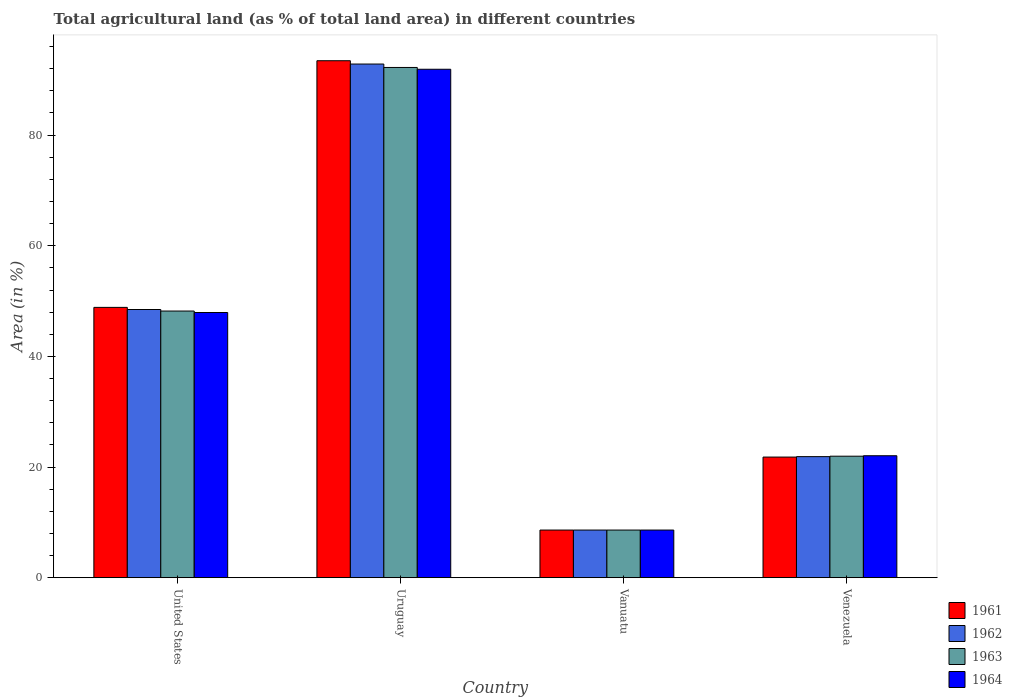How many different coloured bars are there?
Provide a succinct answer. 4. Are the number of bars per tick equal to the number of legend labels?
Your answer should be compact. Yes. What is the label of the 4th group of bars from the left?
Your answer should be very brief. Venezuela. What is the percentage of agricultural land in 1964 in Vanuatu?
Your answer should be very brief. 8.61. Across all countries, what is the maximum percentage of agricultural land in 1964?
Your response must be concise. 91.9. Across all countries, what is the minimum percentage of agricultural land in 1962?
Your answer should be very brief. 8.61. In which country was the percentage of agricultural land in 1961 maximum?
Give a very brief answer. Uruguay. In which country was the percentage of agricultural land in 1962 minimum?
Provide a succinct answer. Vanuatu. What is the total percentage of agricultural land in 1962 in the graph?
Ensure brevity in your answer.  171.81. What is the difference between the percentage of agricultural land in 1964 in Uruguay and that in Venezuela?
Provide a succinct answer. 69.85. What is the difference between the percentage of agricultural land in 1962 in Uruguay and the percentage of agricultural land in 1963 in United States?
Make the answer very short. 44.64. What is the average percentage of agricultural land in 1961 per country?
Your answer should be compact. 43.18. What is the difference between the percentage of agricultural land of/in 1963 and percentage of agricultural land of/in 1962 in Venezuela?
Ensure brevity in your answer.  0.08. What is the ratio of the percentage of agricultural land in 1961 in United States to that in Vanuatu?
Offer a terse response. 5.67. Is the difference between the percentage of agricultural land in 1963 in Vanuatu and Venezuela greater than the difference between the percentage of agricultural land in 1962 in Vanuatu and Venezuela?
Your response must be concise. No. What is the difference between the highest and the second highest percentage of agricultural land in 1962?
Provide a short and direct response. -44.36. What is the difference between the highest and the lowest percentage of agricultural land in 1961?
Offer a very short reply. 84.83. In how many countries, is the percentage of agricultural land in 1962 greater than the average percentage of agricultural land in 1962 taken over all countries?
Offer a terse response. 2. Is the sum of the percentage of agricultural land in 1964 in Uruguay and Venezuela greater than the maximum percentage of agricultural land in 1961 across all countries?
Provide a succinct answer. Yes. Are all the bars in the graph horizontal?
Make the answer very short. No. How many countries are there in the graph?
Your answer should be compact. 4. How are the legend labels stacked?
Make the answer very short. Vertical. What is the title of the graph?
Give a very brief answer. Total agricultural land (as % of total land area) in different countries. Does "2008" appear as one of the legend labels in the graph?
Your answer should be very brief. No. What is the label or title of the Y-axis?
Provide a succinct answer. Area (in %). What is the Area (in %) of 1961 in United States?
Offer a terse response. 48.86. What is the Area (in %) in 1962 in United States?
Provide a short and direct response. 48.48. What is the Area (in %) in 1963 in United States?
Your answer should be compact. 48.2. What is the Area (in %) in 1964 in United States?
Your answer should be very brief. 47.93. What is the Area (in %) in 1961 in Uruguay?
Make the answer very short. 93.44. What is the Area (in %) of 1962 in Uruguay?
Your answer should be compact. 92.84. What is the Area (in %) of 1963 in Uruguay?
Provide a succinct answer. 92.22. What is the Area (in %) in 1964 in Uruguay?
Provide a succinct answer. 91.9. What is the Area (in %) in 1961 in Vanuatu?
Provide a succinct answer. 8.61. What is the Area (in %) in 1962 in Vanuatu?
Provide a succinct answer. 8.61. What is the Area (in %) in 1963 in Vanuatu?
Make the answer very short. 8.61. What is the Area (in %) of 1964 in Vanuatu?
Provide a short and direct response. 8.61. What is the Area (in %) in 1961 in Venezuela?
Provide a succinct answer. 21.8. What is the Area (in %) of 1962 in Venezuela?
Offer a very short reply. 21.88. What is the Area (in %) in 1963 in Venezuela?
Give a very brief answer. 21.96. What is the Area (in %) in 1964 in Venezuela?
Ensure brevity in your answer.  22.04. Across all countries, what is the maximum Area (in %) in 1961?
Your answer should be very brief. 93.44. Across all countries, what is the maximum Area (in %) in 1962?
Offer a very short reply. 92.84. Across all countries, what is the maximum Area (in %) in 1963?
Provide a succinct answer. 92.22. Across all countries, what is the maximum Area (in %) in 1964?
Keep it short and to the point. 91.9. Across all countries, what is the minimum Area (in %) of 1961?
Ensure brevity in your answer.  8.61. Across all countries, what is the minimum Area (in %) in 1962?
Offer a very short reply. 8.61. Across all countries, what is the minimum Area (in %) of 1963?
Your answer should be very brief. 8.61. Across all countries, what is the minimum Area (in %) of 1964?
Offer a terse response. 8.61. What is the total Area (in %) in 1961 in the graph?
Offer a very short reply. 172.72. What is the total Area (in %) of 1962 in the graph?
Provide a succinct answer. 171.81. What is the total Area (in %) in 1963 in the graph?
Make the answer very short. 171. What is the total Area (in %) of 1964 in the graph?
Provide a succinct answer. 170.49. What is the difference between the Area (in %) of 1961 in United States and that in Uruguay?
Ensure brevity in your answer.  -44.58. What is the difference between the Area (in %) of 1962 in United States and that in Uruguay?
Your answer should be compact. -44.36. What is the difference between the Area (in %) of 1963 in United States and that in Uruguay?
Offer a terse response. -44.03. What is the difference between the Area (in %) in 1964 in United States and that in Uruguay?
Provide a short and direct response. -43.97. What is the difference between the Area (in %) in 1961 in United States and that in Vanuatu?
Keep it short and to the point. 40.25. What is the difference between the Area (in %) in 1962 in United States and that in Vanuatu?
Provide a succinct answer. 39.86. What is the difference between the Area (in %) of 1963 in United States and that in Vanuatu?
Make the answer very short. 39.58. What is the difference between the Area (in %) in 1964 in United States and that in Vanuatu?
Ensure brevity in your answer.  39.32. What is the difference between the Area (in %) of 1961 in United States and that in Venezuela?
Provide a succinct answer. 27.06. What is the difference between the Area (in %) of 1962 in United States and that in Venezuela?
Offer a very short reply. 26.59. What is the difference between the Area (in %) of 1963 in United States and that in Venezuela?
Give a very brief answer. 26.24. What is the difference between the Area (in %) in 1964 in United States and that in Venezuela?
Provide a short and direct response. 25.89. What is the difference between the Area (in %) in 1961 in Uruguay and that in Vanuatu?
Provide a short and direct response. 84.83. What is the difference between the Area (in %) of 1962 in Uruguay and that in Vanuatu?
Your answer should be compact. 84.23. What is the difference between the Area (in %) in 1963 in Uruguay and that in Vanuatu?
Make the answer very short. 83.61. What is the difference between the Area (in %) in 1964 in Uruguay and that in Vanuatu?
Offer a terse response. 83.28. What is the difference between the Area (in %) in 1961 in Uruguay and that in Venezuela?
Offer a very short reply. 71.64. What is the difference between the Area (in %) of 1962 in Uruguay and that in Venezuela?
Your answer should be compact. 70.96. What is the difference between the Area (in %) in 1963 in Uruguay and that in Venezuela?
Keep it short and to the point. 70.26. What is the difference between the Area (in %) of 1964 in Uruguay and that in Venezuela?
Provide a short and direct response. 69.85. What is the difference between the Area (in %) of 1961 in Vanuatu and that in Venezuela?
Your response must be concise. -13.19. What is the difference between the Area (in %) in 1962 in Vanuatu and that in Venezuela?
Your answer should be very brief. -13.27. What is the difference between the Area (in %) of 1963 in Vanuatu and that in Venezuela?
Ensure brevity in your answer.  -13.35. What is the difference between the Area (in %) of 1964 in Vanuatu and that in Venezuela?
Keep it short and to the point. -13.43. What is the difference between the Area (in %) of 1961 in United States and the Area (in %) of 1962 in Uruguay?
Your response must be concise. -43.98. What is the difference between the Area (in %) in 1961 in United States and the Area (in %) in 1963 in Uruguay?
Provide a succinct answer. -43.36. What is the difference between the Area (in %) of 1961 in United States and the Area (in %) of 1964 in Uruguay?
Your response must be concise. -43.04. What is the difference between the Area (in %) of 1962 in United States and the Area (in %) of 1963 in Uruguay?
Offer a terse response. -43.75. What is the difference between the Area (in %) in 1962 in United States and the Area (in %) in 1964 in Uruguay?
Give a very brief answer. -43.42. What is the difference between the Area (in %) of 1963 in United States and the Area (in %) of 1964 in Uruguay?
Keep it short and to the point. -43.7. What is the difference between the Area (in %) of 1961 in United States and the Area (in %) of 1962 in Vanuatu?
Make the answer very short. 40.25. What is the difference between the Area (in %) of 1961 in United States and the Area (in %) of 1963 in Vanuatu?
Your response must be concise. 40.25. What is the difference between the Area (in %) in 1961 in United States and the Area (in %) in 1964 in Vanuatu?
Make the answer very short. 40.25. What is the difference between the Area (in %) of 1962 in United States and the Area (in %) of 1963 in Vanuatu?
Give a very brief answer. 39.86. What is the difference between the Area (in %) of 1962 in United States and the Area (in %) of 1964 in Vanuatu?
Keep it short and to the point. 39.86. What is the difference between the Area (in %) in 1963 in United States and the Area (in %) in 1964 in Vanuatu?
Make the answer very short. 39.58. What is the difference between the Area (in %) of 1961 in United States and the Area (in %) of 1962 in Venezuela?
Offer a very short reply. 26.98. What is the difference between the Area (in %) in 1961 in United States and the Area (in %) in 1963 in Venezuela?
Give a very brief answer. 26.9. What is the difference between the Area (in %) of 1961 in United States and the Area (in %) of 1964 in Venezuela?
Provide a succinct answer. 26.82. What is the difference between the Area (in %) in 1962 in United States and the Area (in %) in 1963 in Venezuela?
Offer a very short reply. 26.51. What is the difference between the Area (in %) of 1962 in United States and the Area (in %) of 1964 in Venezuela?
Give a very brief answer. 26.43. What is the difference between the Area (in %) of 1963 in United States and the Area (in %) of 1964 in Venezuela?
Offer a very short reply. 26.15. What is the difference between the Area (in %) of 1961 in Uruguay and the Area (in %) of 1962 in Vanuatu?
Ensure brevity in your answer.  84.83. What is the difference between the Area (in %) of 1961 in Uruguay and the Area (in %) of 1963 in Vanuatu?
Ensure brevity in your answer.  84.83. What is the difference between the Area (in %) in 1961 in Uruguay and the Area (in %) in 1964 in Vanuatu?
Give a very brief answer. 84.83. What is the difference between the Area (in %) of 1962 in Uruguay and the Area (in %) of 1963 in Vanuatu?
Give a very brief answer. 84.23. What is the difference between the Area (in %) of 1962 in Uruguay and the Area (in %) of 1964 in Vanuatu?
Your response must be concise. 84.23. What is the difference between the Area (in %) in 1963 in Uruguay and the Area (in %) in 1964 in Vanuatu?
Ensure brevity in your answer.  83.61. What is the difference between the Area (in %) in 1961 in Uruguay and the Area (in %) in 1962 in Venezuela?
Offer a terse response. 71.56. What is the difference between the Area (in %) of 1961 in Uruguay and the Area (in %) of 1963 in Venezuela?
Offer a terse response. 71.48. What is the difference between the Area (in %) in 1961 in Uruguay and the Area (in %) in 1964 in Venezuela?
Your response must be concise. 71.4. What is the difference between the Area (in %) in 1962 in Uruguay and the Area (in %) in 1963 in Venezuela?
Offer a terse response. 70.88. What is the difference between the Area (in %) in 1962 in Uruguay and the Area (in %) in 1964 in Venezuela?
Offer a very short reply. 70.8. What is the difference between the Area (in %) in 1963 in Uruguay and the Area (in %) in 1964 in Venezuela?
Provide a short and direct response. 70.18. What is the difference between the Area (in %) in 1961 in Vanuatu and the Area (in %) in 1962 in Venezuela?
Provide a short and direct response. -13.27. What is the difference between the Area (in %) of 1961 in Vanuatu and the Area (in %) of 1963 in Venezuela?
Provide a succinct answer. -13.35. What is the difference between the Area (in %) in 1961 in Vanuatu and the Area (in %) in 1964 in Venezuela?
Provide a short and direct response. -13.43. What is the difference between the Area (in %) in 1962 in Vanuatu and the Area (in %) in 1963 in Venezuela?
Offer a very short reply. -13.35. What is the difference between the Area (in %) of 1962 in Vanuatu and the Area (in %) of 1964 in Venezuela?
Your response must be concise. -13.43. What is the difference between the Area (in %) in 1963 in Vanuatu and the Area (in %) in 1964 in Venezuela?
Your answer should be very brief. -13.43. What is the average Area (in %) of 1961 per country?
Offer a very short reply. 43.18. What is the average Area (in %) in 1962 per country?
Your answer should be compact. 42.95. What is the average Area (in %) of 1963 per country?
Keep it short and to the point. 42.75. What is the average Area (in %) of 1964 per country?
Offer a very short reply. 42.62. What is the difference between the Area (in %) of 1961 and Area (in %) of 1962 in United States?
Provide a succinct answer. 0.38. What is the difference between the Area (in %) of 1961 and Area (in %) of 1963 in United States?
Provide a short and direct response. 0.66. What is the difference between the Area (in %) in 1961 and Area (in %) in 1964 in United States?
Keep it short and to the point. 0.93. What is the difference between the Area (in %) of 1962 and Area (in %) of 1963 in United States?
Your response must be concise. 0.28. What is the difference between the Area (in %) in 1962 and Area (in %) in 1964 in United States?
Offer a very short reply. 0.54. What is the difference between the Area (in %) of 1963 and Area (in %) of 1964 in United States?
Provide a short and direct response. 0.27. What is the difference between the Area (in %) of 1961 and Area (in %) of 1962 in Uruguay?
Give a very brief answer. 0.6. What is the difference between the Area (in %) of 1961 and Area (in %) of 1963 in Uruguay?
Make the answer very short. 1.22. What is the difference between the Area (in %) in 1961 and Area (in %) in 1964 in Uruguay?
Your response must be concise. 1.54. What is the difference between the Area (in %) in 1962 and Area (in %) in 1963 in Uruguay?
Give a very brief answer. 0.62. What is the difference between the Area (in %) in 1962 and Area (in %) in 1964 in Uruguay?
Keep it short and to the point. 0.94. What is the difference between the Area (in %) in 1963 and Area (in %) in 1964 in Uruguay?
Your answer should be compact. 0.33. What is the difference between the Area (in %) in 1961 and Area (in %) in 1962 in Vanuatu?
Offer a terse response. 0. What is the difference between the Area (in %) in 1961 and Area (in %) in 1964 in Vanuatu?
Keep it short and to the point. 0. What is the difference between the Area (in %) in 1962 and Area (in %) in 1963 in Vanuatu?
Your response must be concise. 0. What is the difference between the Area (in %) in 1963 and Area (in %) in 1964 in Vanuatu?
Your answer should be compact. 0. What is the difference between the Area (in %) of 1961 and Area (in %) of 1962 in Venezuela?
Keep it short and to the point. -0.08. What is the difference between the Area (in %) of 1961 and Area (in %) of 1963 in Venezuela?
Your answer should be compact. -0.16. What is the difference between the Area (in %) in 1961 and Area (in %) in 1964 in Venezuela?
Keep it short and to the point. -0.24. What is the difference between the Area (in %) in 1962 and Area (in %) in 1963 in Venezuela?
Keep it short and to the point. -0.08. What is the difference between the Area (in %) of 1962 and Area (in %) of 1964 in Venezuela?
Your answer should be compact. -0.16. What is the difference between the Area (in %) of 1963 and Area (in %) of 1964 in Venezuela?
Give a very brief answer. -0.08. What is the ratio of the Area (in %) in 1961 in United States to that in Uruguay?
Provide a succinct answer. 0.52. What is the ratio of the Area (in %) in 1962 in United States to that in Uruguay?
Make the answer very short. 0.52. What is the ratio of the Area (in %) of 1963 in United States to that in Uruguay?
Make the answer very short. 0.52. What is the ratio of the Area (in %) in 1964 in United States to that in Uruguay?
Your response must be concise. 0.52. What is the ratio of the Area (in %) of 1961 in United States to that in Vanuatu?
Give a very brief answer. 5.67. What is the ratio of the Area (in %) in 1962 in United States to that in Vanuatu?
Provide a short and direct response. 5.63. What is the ratio of the Area (in %) in 1963 in United States to that in Vanuatu?
Give a very brief answer. 5.6. What is the ratio of the Area (in %) in 1964 in United States to that in Vanuatu?
Keep it short and to the point. 5.56. What is the ratio of the Area (in %) in 1961 in United States to that in Venezuela?
Ensure brevity in your answer.  2.24. What is the ratio of the Area (in %) of 1962 in United States to that in Venezuela?
Ensure brevity in your answer.  2.22. What is the ratio of the Area (in %) of 1963 in United States to that in Venezuela?
Your answer should be compact. 2.19. What is the ratio of the Area (in %) of 1964 in United States to that in Venezuela?
Your answer should be very brief. 2.17. What is the ratio of the Area (in %) of 1961 in Uruguay to that in Vanuatu?
Keep it short and to the point. 10.85. What is the ratio of the Area (in %) of 1962 in Uruguay to that in Vanuatu?
Your answer should be very brief. 10.78. What is the ratio of the Area (in %) of 1963 in Uruguay to that in Vanuatu?
Your answer should be compact. 10.71. What is the ratio of the Area (in %) in 1964 in Uruguay to that in Vanuatu?
Offer a terse response. 10.67. What is the ratio of the Area (in %) of 1961 in Uruguay to that in Venezuela?
Provide a short and direct response. 4.29. What is the ratio of the Area (in %) of 1962 in Uruguay to that in Venezuela?
Your answer should be compact. 4.24. What is the ratio of the Area (in %) of 1963 in Uruguay to that in Venezuela?
Your response must be concise. 4.2. What is the ratio of the Area (in %) of 1964 in Uruguay to that in Venezuela?
Offer a terse response. 4.17. What is the ratio of the Area (in %) in 1961 in Vanuatu to that in Venezuela?
Keep it short and to the point. 0.4. What is the ratio of the Area (in %) in 1962 in Vanuatu to that in Venezuela?
Your answer should be compact. 0.39. What is the ratio of the Area (in %) of 1963 in Vanuatu to that in Venezuela?
Offer a very short reply. 0.39. What is the ratio of the Area (in %) of 1964 in Vanuatu to that in Venezuela?
Keep it short and to the point. 0.39. What is the difference between the highest and the second highest Area (in %) in 1961?
Keep it short and to the point. 44.58. What is the difference between the highest and the second highest Area (in %) of 1962?
Provide a short and direct response. 44.36. What is the difference between the highest and the second highest Area (in %) of 1963?
Provide a short and direct response. 44.03. What is the difference between the highest and the second highest Area (in %) of 1964?
Offer a terse response. 43.97. What is the difference between the highest and the lowest Area (in %) of 1961?
Offer a very short reply. 84.83. What is the difference between the highest and the lowest Area (in %) of 1962?
Provide a short and direct response. 84.23. What is the difference between the highest and the lowest Area (in %) of 1963?
Provide a short and direct response. 83.61. What is the difference between the highest and the lowest Area (in %) of 1964?
Your response must be concise. 83.28. 